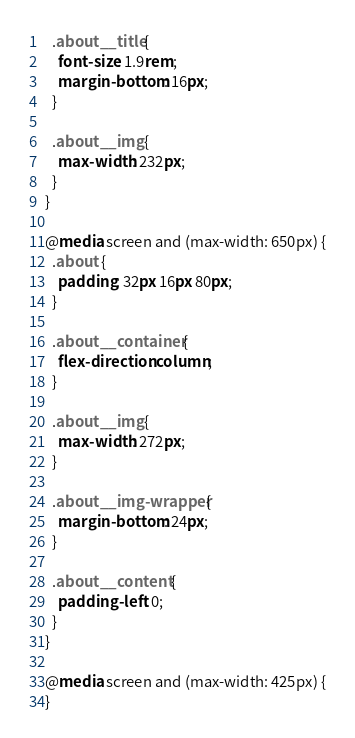<code> <loc_0><loc_0><loc_500><loc_500><_CSS_>  .about__title {
    font-size: 1.9rem;
    margin-bottom: 16px;
  }

  .about__img {
    max-width: 232px;
  }
}

@media screen and (max-width: 650px) {
  .about {
    padding: 32px 16px 80px;
  }

  .about__container {
    flex-direction: column;
  }

  .about__img {
    max-width: 272px;
  }

  .about__img-wrapper {
    margin-bottom: 24px;
  }

  .about__content {
    padding-left: 0;
  }
}

@media screen and (max-width: 425px) {
}
</code> 